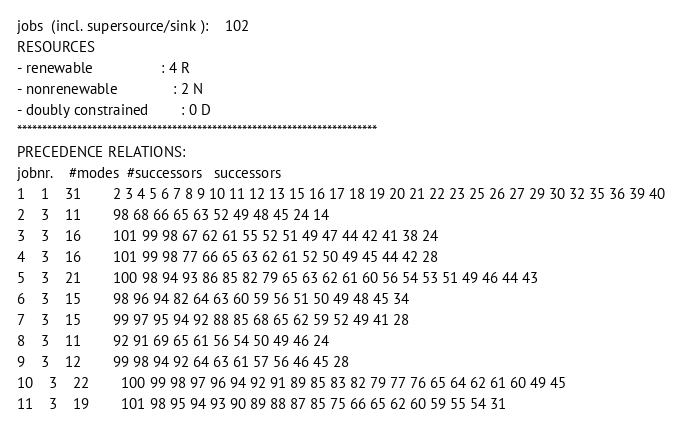<code> <loc_0><loc_0><loc_500><loc_500><_ObjectiveC_>jobs  (incl. supersource/sink ):	102
RESOURCES
- renewable                 : 4 R
- nonrenewable              : 2 N
- doubly constrained        : 0 D
************************************************************************
PRECEDENCE RELATIONS:
jobnr.    #modes  #successors   successors
1	1	31		2 3 4 5 6 7 8 9 10 11 12 13 15 16 17 18 19 20 21 22 23 25 26 27 29 30 32 35 36 39 40 
2	3	11		98 68 66 65 63 52 49 48 45 24 14 
3	3	16		101 99 98 67 62 61 55 52 51 49 47 44 42 41 38 24 
4	3	16		101 99 98 77 66 65 63 62 61 52 50 49 45 44 42 28 
5	3	21		100 98 94 93 86 85 82 79 65 63 62 61 60 56 54 53 51 49 46 44 43 
6	3	15		98 96 94 82 64 63 60 59 56 51 50 49 48 45 34 
7	3	15		99 97 95 94 92 88 85 68 65 62 59 52 49 41 28 
8	3	11		92 91 69 65 61 56 54 50 49 46 24 
9	3	12		99 98 94 92 64 63 61 57 56 46 45 28 
10	3	22		100 99 98 97 96 94 92 91 89 85 83 82 79 77 76 65 64 62 61 60 49 45 
11	3	19		101 98 95 94 93 90 89 88 87 85 75 66 65 62 60 59 55 54 31 </code> 